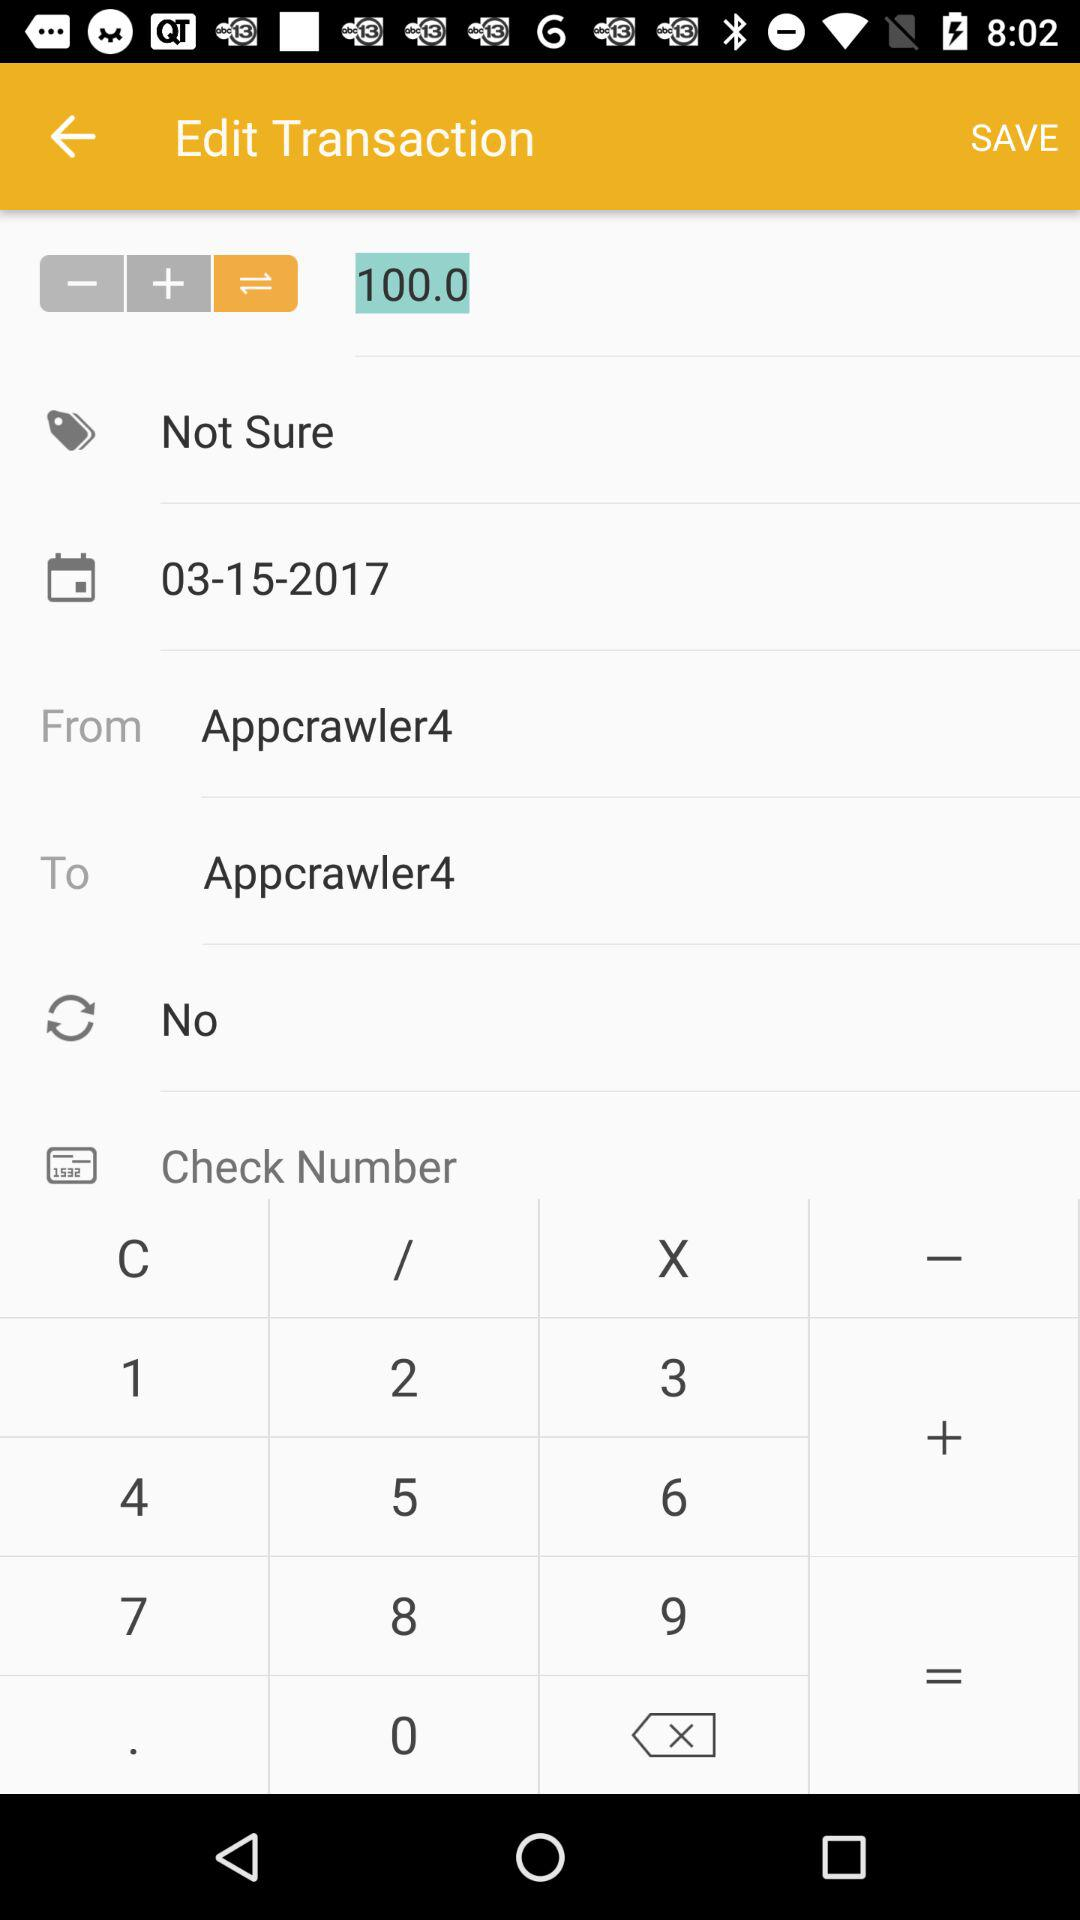What is the date shown on the screen? The date shown on the screen is March 15, 2017. 